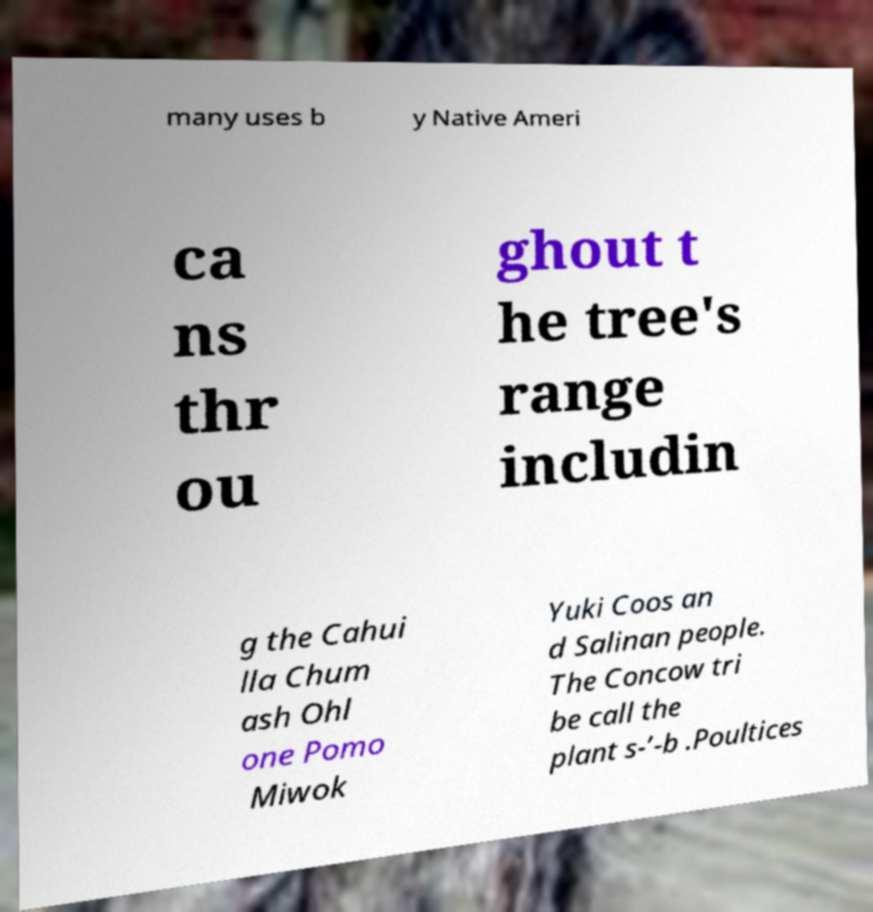I need the written content from this picture converted into text. Can you do that? many uses b y Native Ameri ca ns thr ou ghout t he tree's range includin g the Cahui lla Chum ash Ohl one Pomo Miwok Yuki Coos an d Salinan people. The Concow tri be call the plant s-’-b .Poultices 